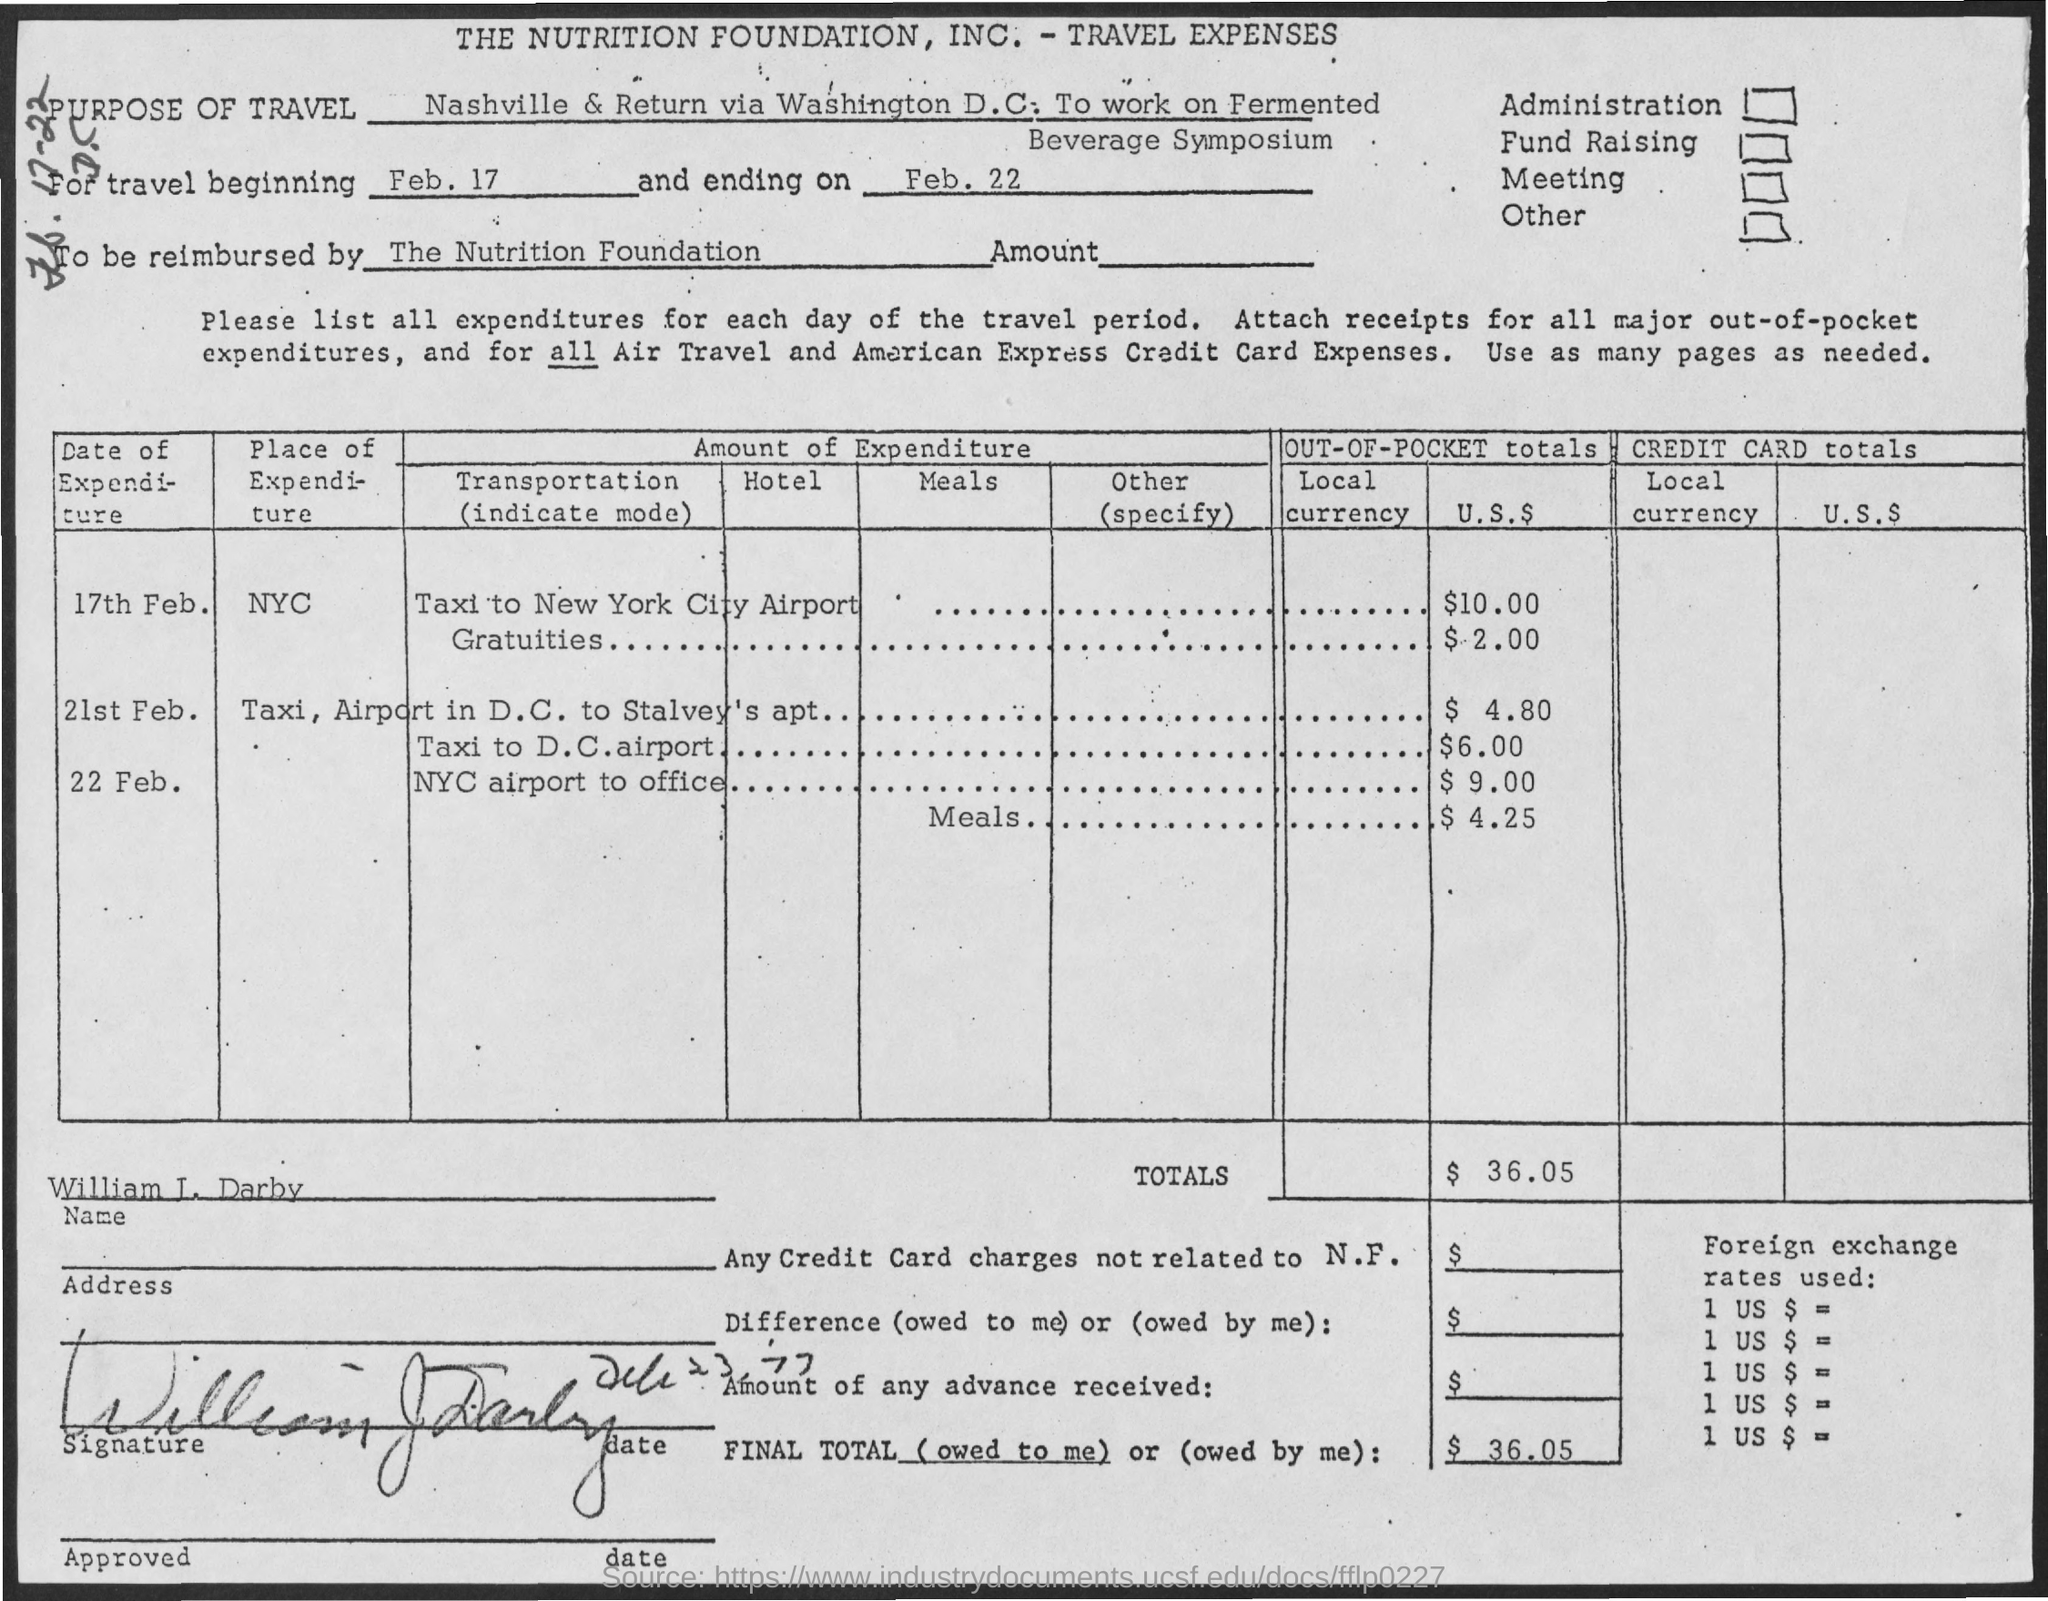Identify some key points in this picture. The travel ending date is February 22nd. 